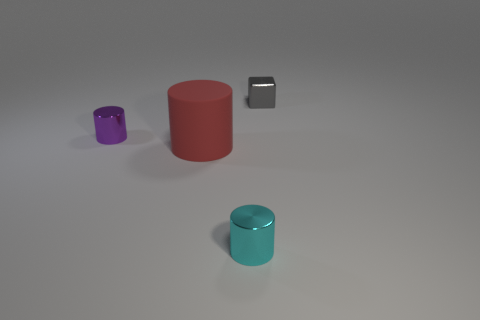What number of cylinders have the same size as the purple metal object?
Keep it short and to the point. 1. There is a tiny cyan thing that is the same shape as the small purple thing; what material is it?
Your response must be concise. Metal. There is a tiny object that is in front of the purple object; what is its color?
Offer a very short reply. Cyan. Are there more small cyan objects that are on the left side of the small purple cylinder than small brown cylinders?
Keep it short and to the point. No. The metal cube is what color?
Provide a succinct answer. Gray. What is the shape of the metal object that is left of the small cylinder in front of the metal cylinder behind the cyan metallic cylinder?
Ensure brevity in your answer.  Cylinder. The thing that is left of the cyan shiny object and behind the red rubber cylinder is made of what material?
Offer a very short reply. Metal. There is a thing behind the small cylinder behind the tiny cyan metal thing; what shape is it?
Your answer should be very brief. Cube. Are there any other things of the same color as the small metallic block?
Ensure brevity in your answer.  No. Does the red matte object have the same size as the shiny thing in front of the big red cylinder?
Provide a short and direct response. No. 